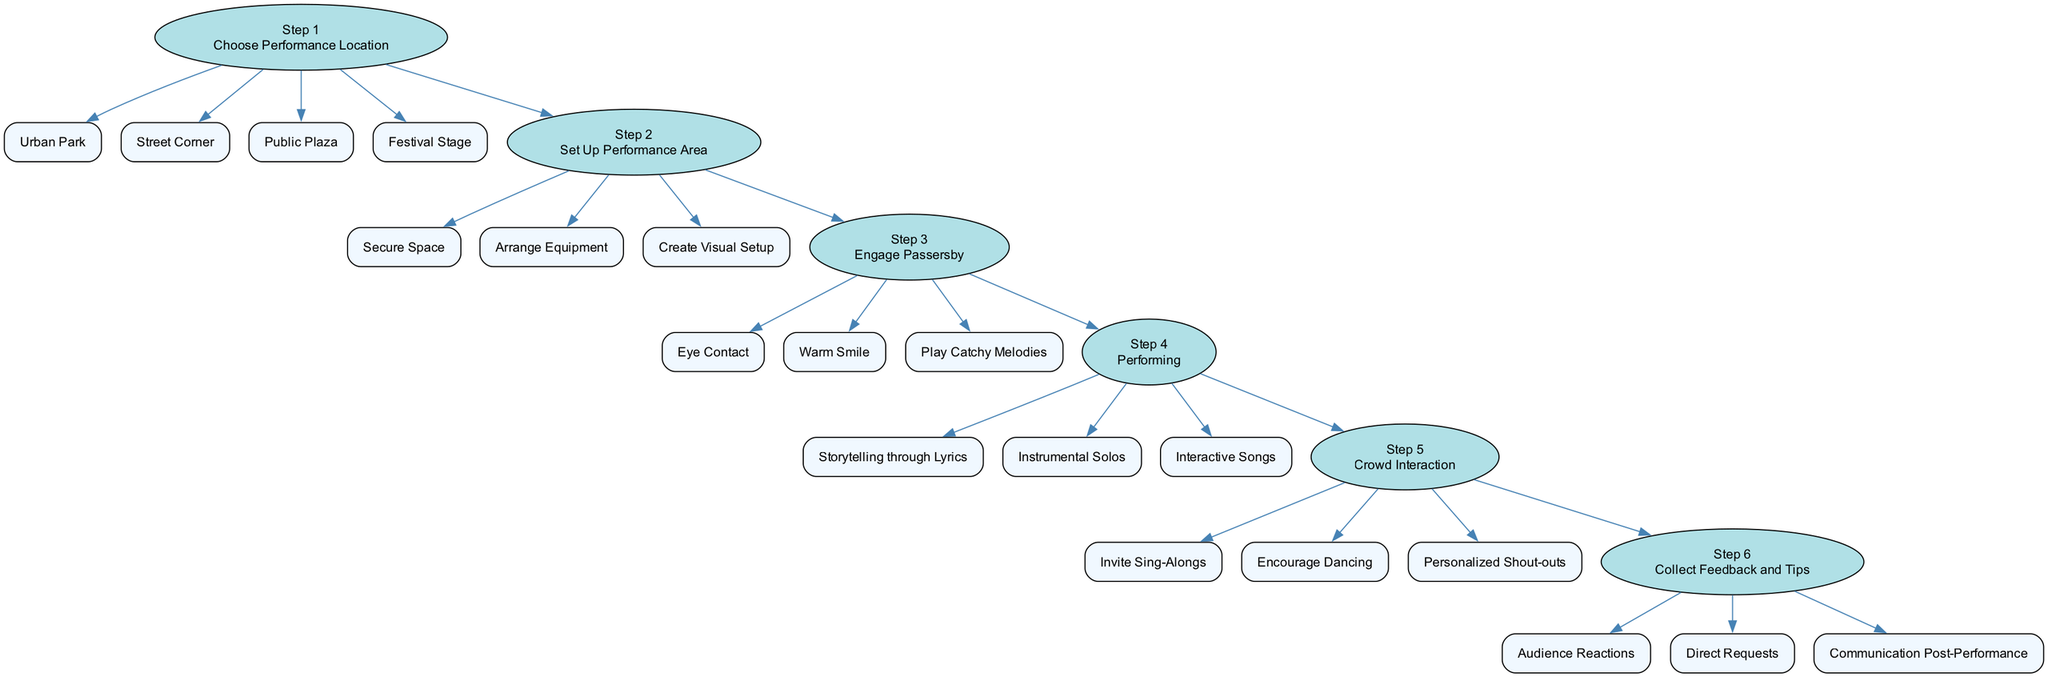What is the first step in the flow chart? The first step in the flow chart is listed directly as the first item, which states "Choose Performance Location".
Answer: Choose Performance Location How many performance location options are provided? The flow chart specifies four options under the first step, which are "Urban Park", "Street Corner", "Public Plaza", and "Festival Stage". This can be counted directly from the diagram.
Answer: 4 What is one technique used to engage passersby? Under the third step, it shows three techniques, one of which is "Warm Smile". Any of these could be an answer, but the request for just one allows for one easy selection.
Answer: Warm Smile Which step involves methods of crowd interaction? By examining the flow chart, the methods of crowd interaction are clearly specified under step five, which is labeled "Crowd Interaction". Thus, reviewing the respective step gives the answer.
Answer: Step 5 What are the feedback sources mentioned in the flow chart? The flow chart describes three specific feedback sources within step six: "Audience Reactions", "Direct Requests", and "Communication Post-Performance". Listing these provides the answer.
Answer: Audience Reactions, Direct Requests, Communication Post-Performance How does one connect the step of setting up the performance area to engaging the crowd? Following the flow of the diagram, you can see that after "Set Up Performance Area" (step 2), the next step is "Engage Passersby" (step 3). This shows a direct and sequential connection between these two steps in the performance flow.
Answer: Step 3 Using which style can a guitarist perform? The flow chart lists three styles under the fourth step, one being "Storytelling through Lyrics". Selecting any of these styles satisfies the inquiry, but one is specifically requested.
Answer: Storytelling through Lyrics What action occurs after performing? According to the flow chart, after the "Performing" step, the next action listed is "Crowd Interaction" (step 5). This indicates the direct flow of activities in performance.
Answer: Crowd Interaction What technique is used for audience engagement in step three? The third step lists three techniques for engaging passersby, including "Play Catchy Melodies". This specifically identifies one engagement method.
Answer: Play Catchy Melodies 